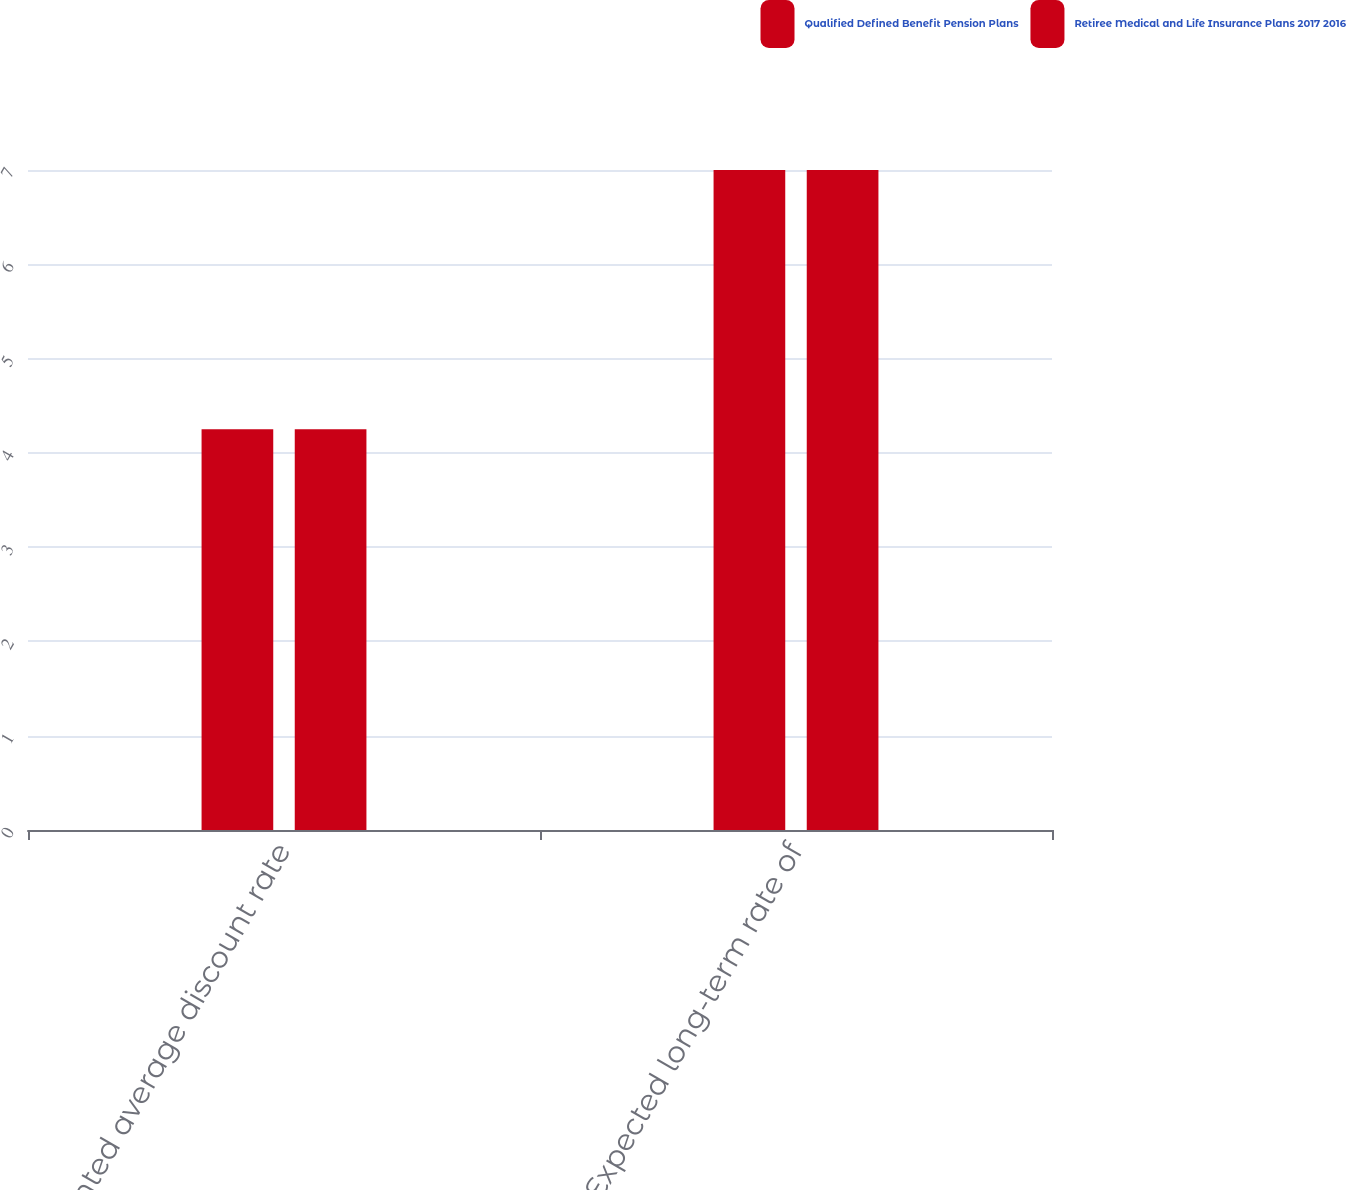Convert chart to OTSL. <chart><loc_0><loc_0><loc_500><loc_500><stacked_bar_chart><ecel><fcel>Weighted average discount rate<fcel>Expected long-term rate of<nl><fcel>Qualified Defined Benefit Pension Plans<fcel>4.25<fcel>7<nl><fcel>Retiree Medical and Life Insurance Plans 2017 2016<fcel>4.25<fcel>7<nl></chart> 